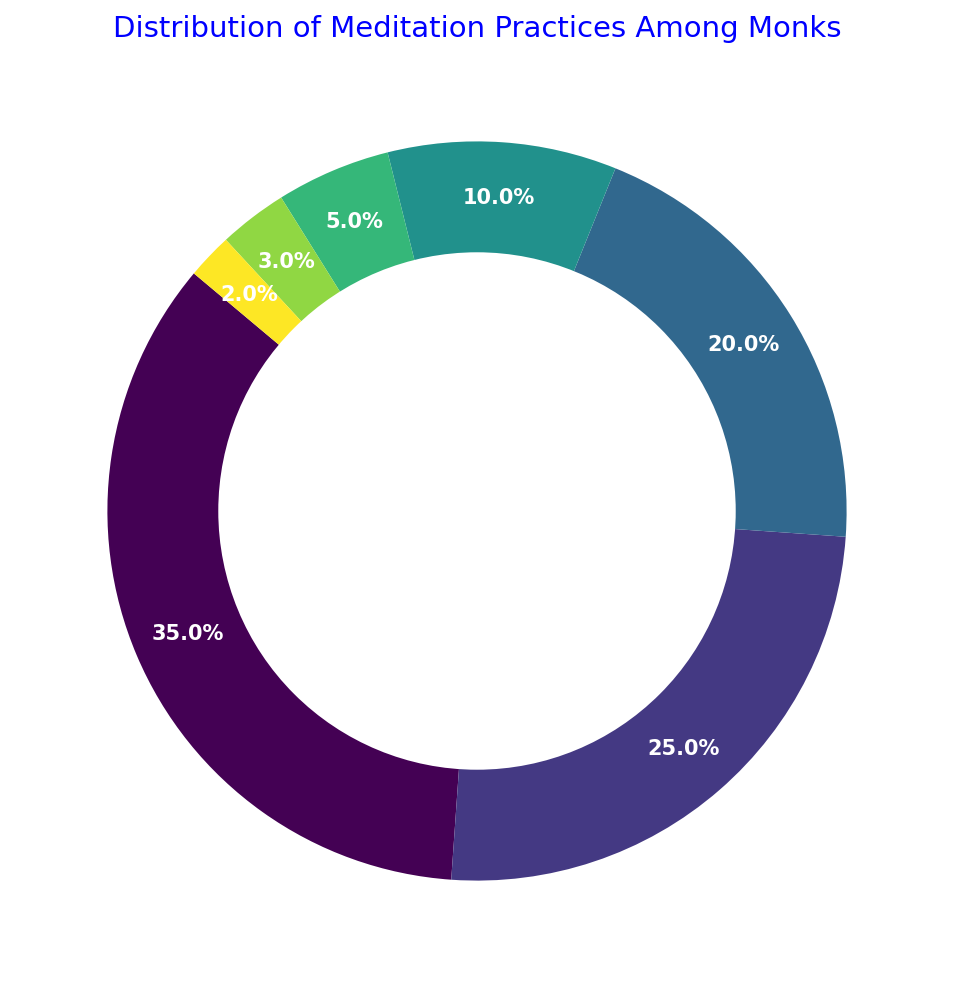What is the percentage of monks practicing Zen? The segment labeled "Zen" shows the percentage value. It reads as 35%.
Answer: 35% Which two meditation practices have the smallest representation among the monks? The smallest segments are labeled "Mantra" and "Loving-Kindness," with percentages of 2% and 3%, respectively.
Answer: Mantra and Loving-Kindness How much more popular is Zen compared to Vipassana among the monks? Zen has a percentage of 35%, and Vipassana has 25%. The difference in popularity is calculated as 35% - 25% = 10%.
Answer: 10% What is the combined percentage of monks practicing Metta and Tibetan practices? Metta and Tibetan have 20% and 10% respectively. Summing them gives 20% + 10% = 30%.
Answer: 30% Which meditation practice is second in popularity and what is its percentage? The segment labeled "Vipassana" has the second-largest percentage, which is 25%.
Answer: Vipassana, 25% What is the total percentage of monks practicing Body Scan and Metta combined? Body Scan has 5% and Metta has 20%. Combined, it's 5% + 20% = 25%.
Answer: 25% How does the percentage of monks practicing Tibetan compare to those practicing Vipassana? Tibetan has a percentage of 10%, and Vipassana has 25%. Tibetan is less popular by a difference of 25% - 10% = 15%.
Answer: Tibetan is 15% less than Vipassana Which color is used for the Zen practice segment? Looking at the pie chart, the Zen segment is the largest one and is shown in a specific color, which can be observed on the figure.
Answer: [The specific color used in the chart] If we were to combine the percentages of Loving-Kindness, Mantra, and Body Scan practices, what would be the total percentage? The percentages are 3%, 2%, and 5% respectively. Summing them gives 3% + 2% + 5% = 10%.
Answer: 10% What is the difference in popularity between the third and fourth most practiced meditation techniques? Metta is the third most popular with 20%, and Tibetan is the fourth with 10%. The difference is 20% - 10% = 10%.
Answer: 10% 